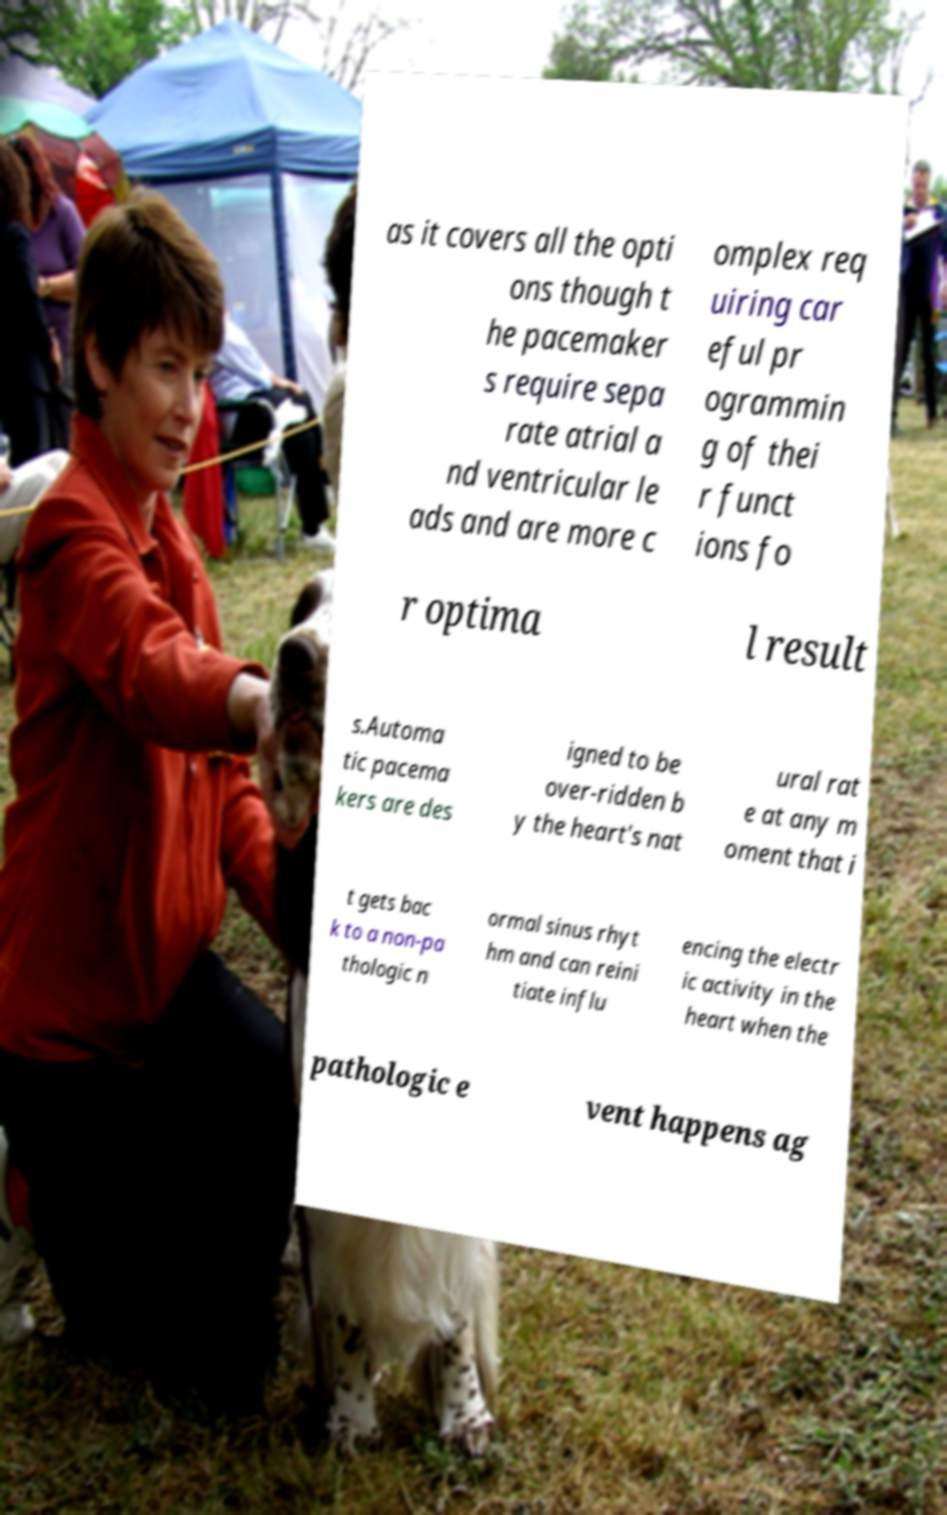Please read and relay the text visible in this image. What does it say? as it covers all the opti ons though t he pacemaker s require sepa rate atrial a nd ventricular le ads and are more c omplex req uiring car eful pr ogrammin g of thei r funct ions fo r optima l result s.Automa tic pacema kers are des igned to be over-ridden b y the heart's nat ural rat e at any m oment that i t gets bac k to a non-pa thologic n ormal sinus rhyt hm and can reini tiate influ encing the electr ic activity in the heart when the pathologic e vent happens ag 